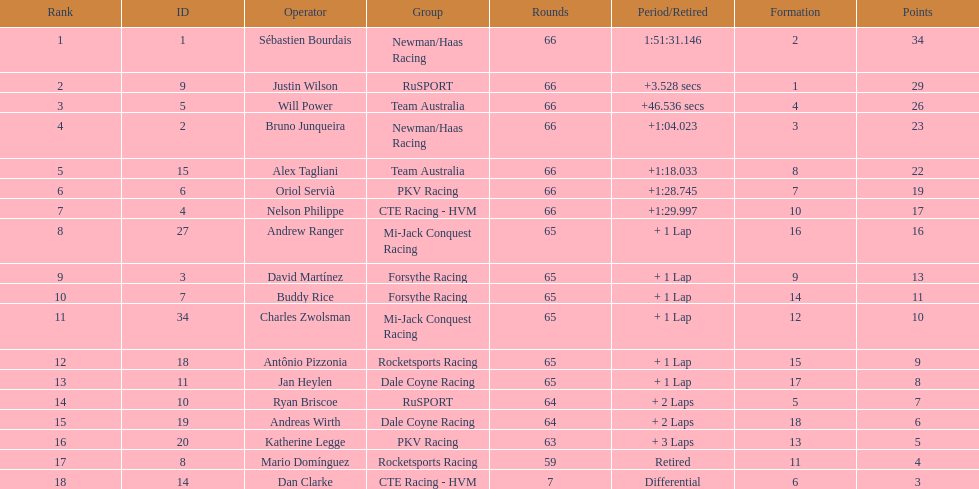Which teams participated in the 2006 gran premio telmex? Newman/Haas Racing, RuSPORT, Team Australia, Newman/Haas Racing, Team Australia, PKV Racing, CTE Racing - HVM, Mi-Jack Conquest Racing, Forsythe Racing, Forsythe Racing, Mi-Jack Conquest Racing, Rocketsports Racing, Dale Coyne Racing, RuSPORT, Dale Coyne Racing, PKV Racing, Rocketsports Racing, CTE Racing - HVM. Who were the drivers of these teams? Sébastien Bourdais, Justin Wilson, Will Power, Bruno Junqueira, Alex Tagliani, Oriol Servià, Nelson Philippe, Andrew Ranger, David Martínez, Buddy Rice, Charles Zwolsman, Antônio Pizzonia, Jan Heylen, Ryan Briscoe, Andreas Wirth, Katherine Legge, Mario Domínguez, Dan Clarke. Which driver finished last? Dan Clarke. 